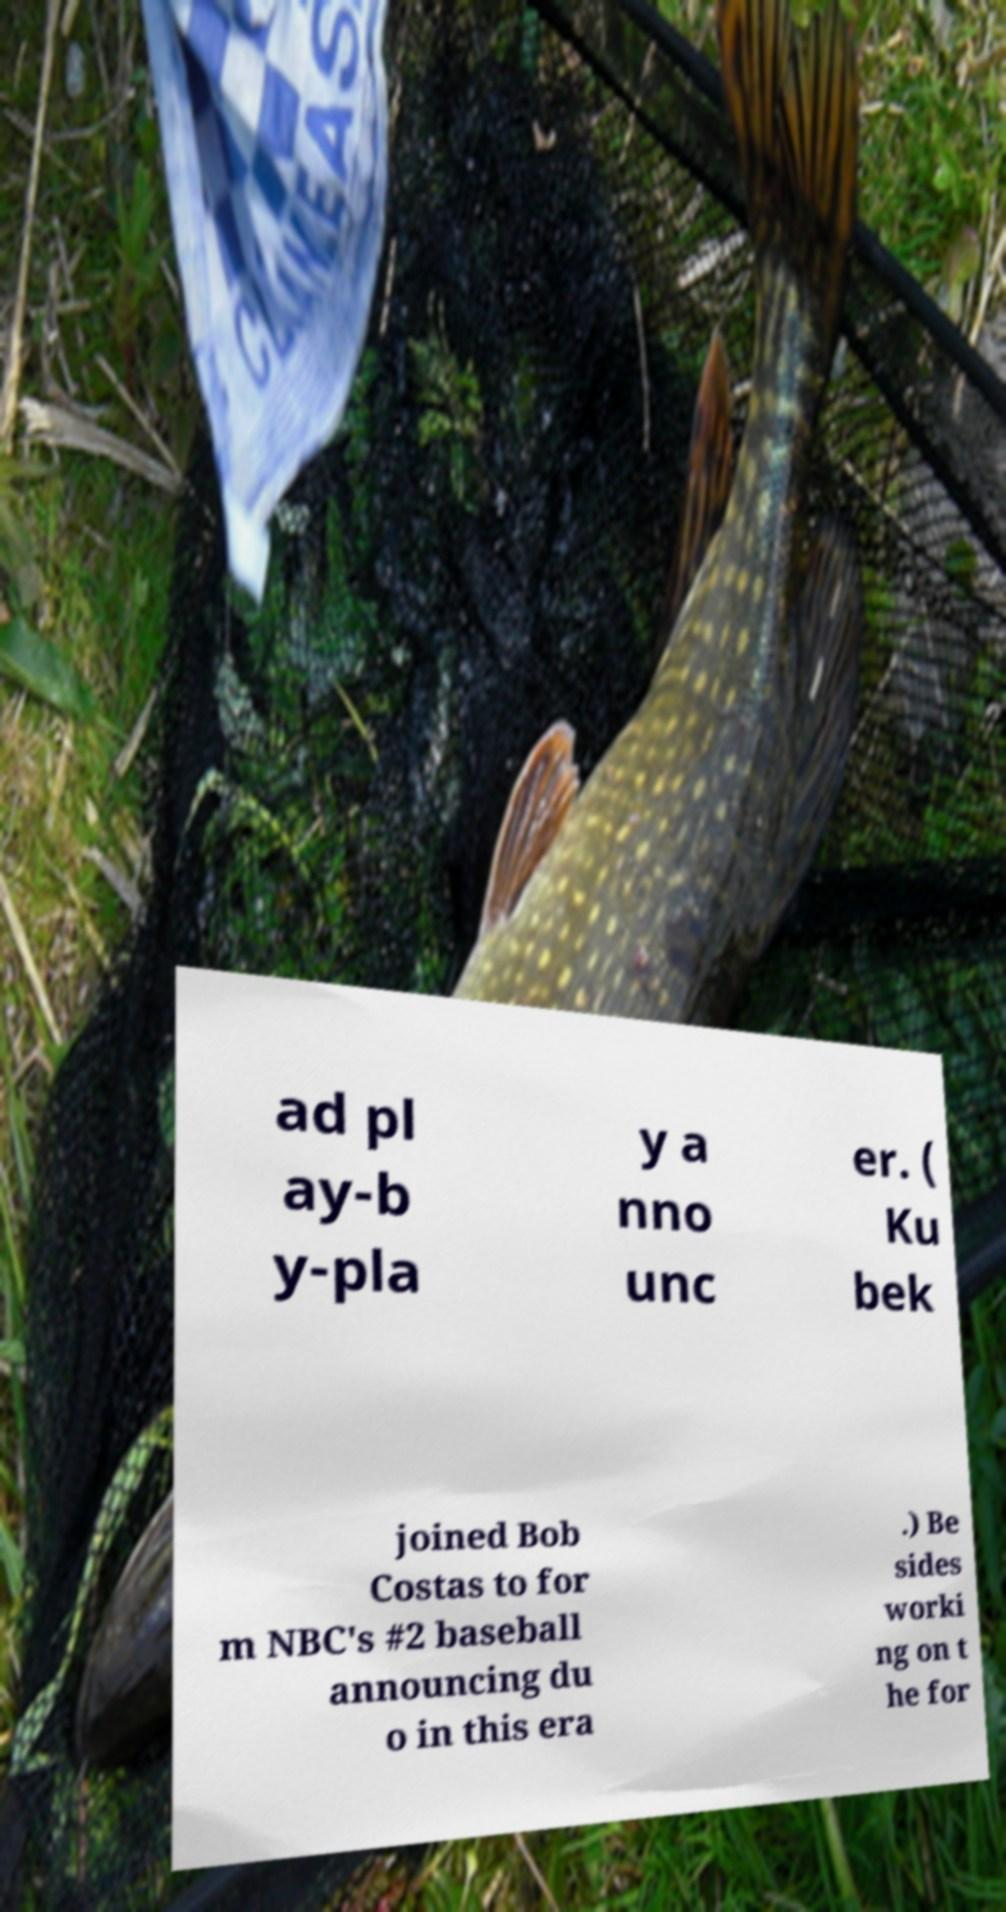What messages or text are displayed in this image? I need them in a readable, typed format. ad pl ay-b y-pla y a nno unc er. ( Ku bek joined Bob Costas to for m NBC's #2 baseball announcing du o in this era .) Be sides worki ng on t he for 